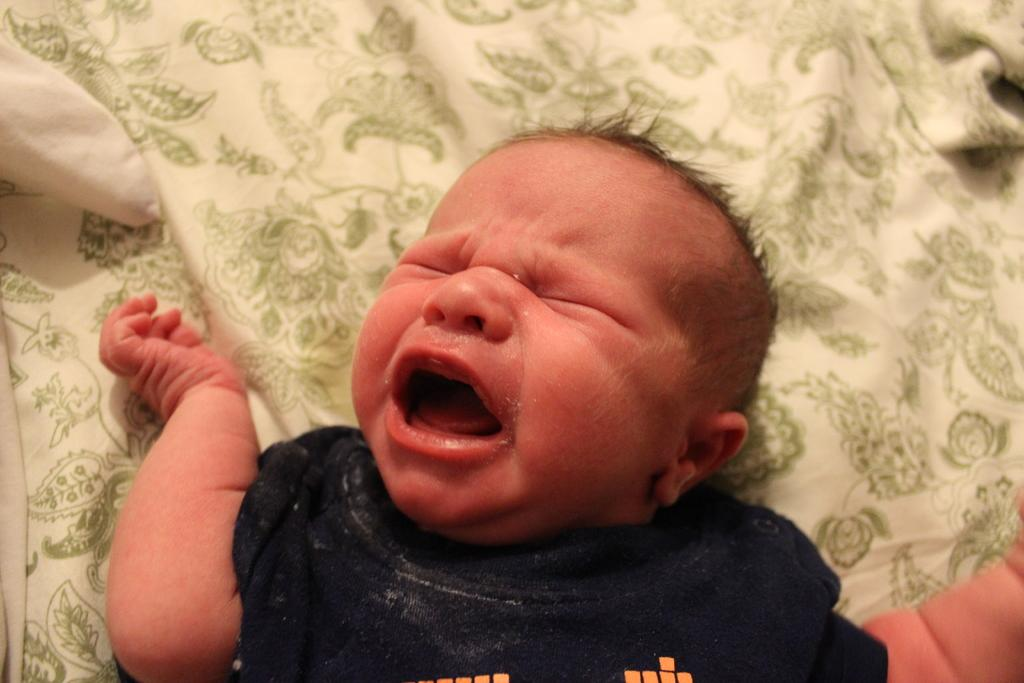What is the main subject of the image? The main subject of the image is a baby. Where is the baby located in the image? The baby is on a bed. What is the baby doing in the image? The baby is crying. What else can be seen in the image? There is a pillow in the image. What time of day is the baby waking up in the image? The time of day is not mentioned in the image, so it cannot be determined when the baby is waking up. What type of machine is being used by the baby in the image? There is no machine present in the image; it features a baby on a bed. What is the heart rate of the baby in the image? The heart rate of the baby is not visible in the image, so it cannot be determined. 